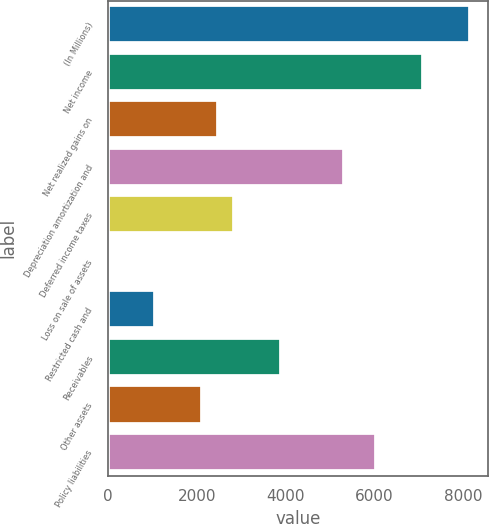Convert chart to OTSL. <chart><loc_0><loc_0><loc_500><loc_500><bar_chart><fcel>(In Millions)<fcel>Net income<fcel>Net realized gains on<fcel>Depreciation amortization and<fcel>Deferred income taxes<fcel>Loss on sale of assets<fcel>Restricted cash and<fcel>Receivables<fcel>Other assets<fcel>Policy liabilities<nl><fcel>8152.39<fcel>7089.1<fcel>2481.51<fcel>5316.95<fcel>2835.94<fcel>0.5<fcel>1063.79<fcel>3899.23<fcel>2127.08<fcel>6025.81<nl></chart> 